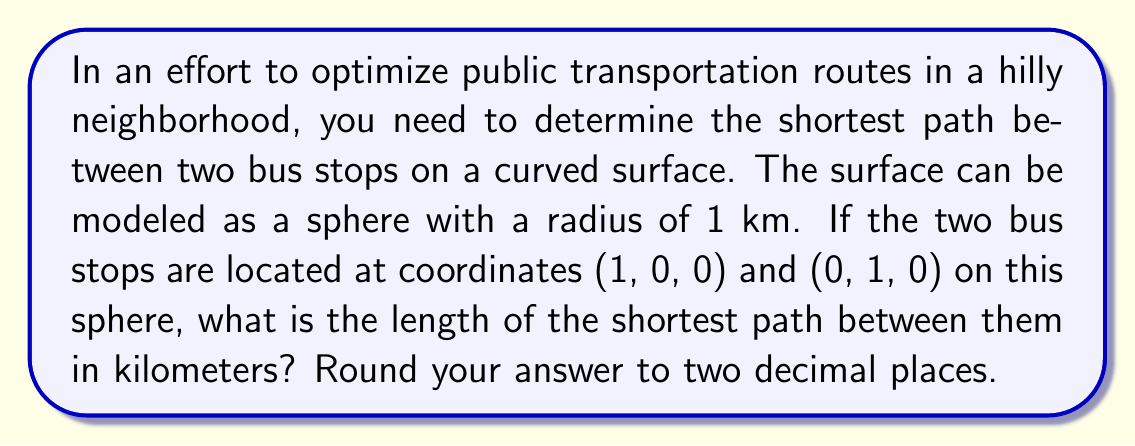Can you answer this question? To solve this problem, we'll use concepts from spherical geometry:

1) The shortest path between two points on a sphere is along a great circle, which is the intersection of the sphere with a plane passing through its center and the two points.

2) The distance between two points on a unit sphere (radius = 1) is given by the arc length formula:
   $$ d = r \cdot \arccos(\sin\phi_1\sin\phi_2 + \cos\phi_1\cos\phi_2\cos(\lambda_2 - \lambda_1)) $$
   where $r$ is the radius, $\phi$ is latitude, and $\lambda$ is longitude.

3) In our case, we're given Cartesian coordinates. We need to convert these to spherical coordinates:
   - (1, 0, 0) corresponds to (φ₁, λ₁) = (0, 0)
   - (0, 1, 0) corresponds to (φ₂, λ₂) = (0, π/2)

4) Plugging these into our formula:
   $$ d = 1 \cdot \arccos(\sin(0)\sin(0) + \cos(0)\cos(0)\cos(\frac{\pi}{2} - 0)) $$

5) Simplify:
   $$ d = \arccos(1 \cdot \cos(\frac{\pi}{2})) = \arccos(0) = \frac{\pi}{2} $$

6) Convert to kilometers:
   $$ d = \frac{\pi}{2} \cdot 1\text{ km} \approx 1.5708\text{ km} $$

7) Rounding to two decimal places: 1.57 km
Answer: 1.57 km 